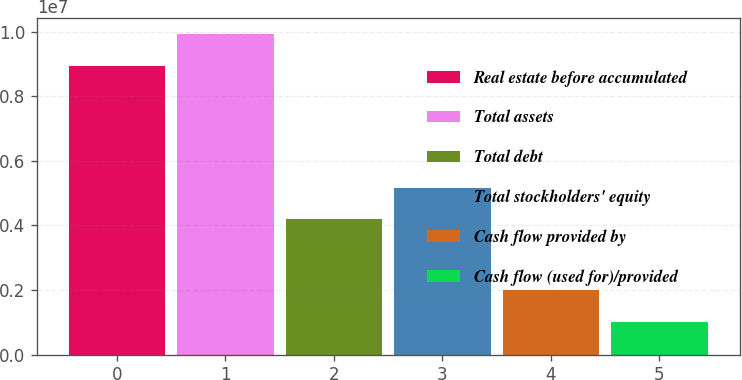Convert chart to OTSL. <chart><loc_0><loc_0><loc_500><loc_500><bar_chart><fcel>Real estate before accumulated<fcel>Total assets<fcel>Total debt<fcel>Total stockholders' equity<fcel>Cash flow provided by<fcel>Cash flow (used for)/provided<nl><fcel>8.94729e+06<fcel>9.91627e+06<fcel>4.19532e+06<fcel>5.1643e+06<fcel>1.98896e+06<fcel>1.01998e+06<nl></chart> 